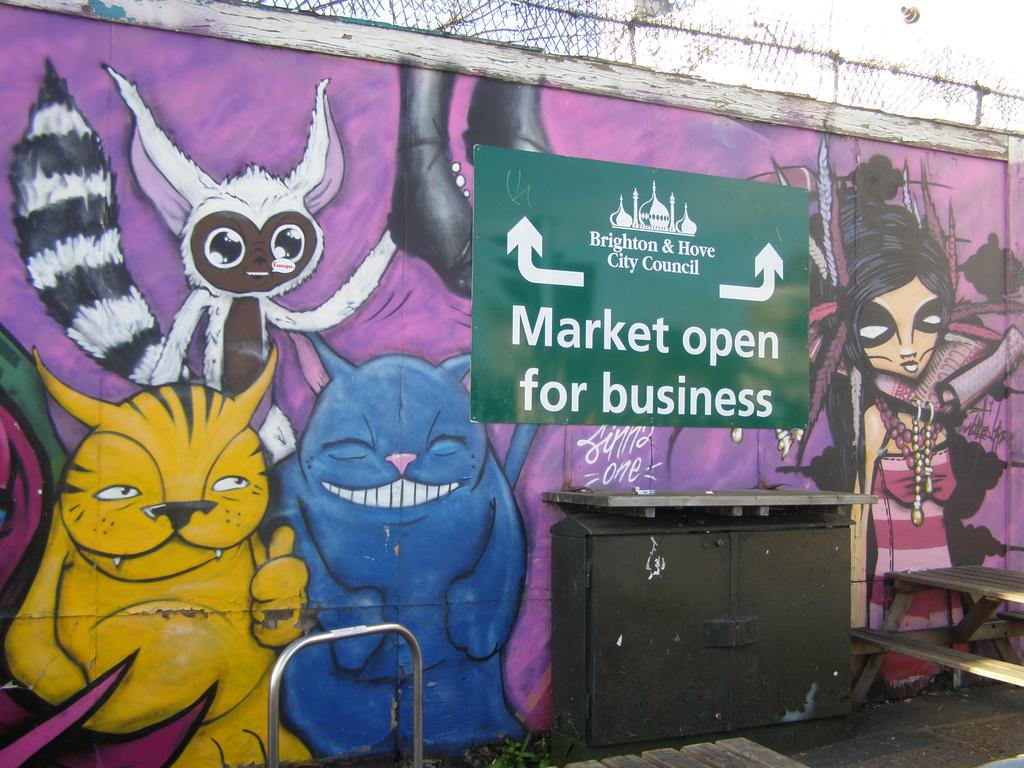What is depicted on the wall in the image? There is a wall with graffiti painting in the image. What else can be seen on the wall besides the graffiti? There is a poster with text in the image. What type of seating is present on the right side of the image? There is a wooden bench on the right side of the image. How does the graffiti painting on the wall affect the top of the poster? There is no interaction between the graffiti painting and the poster in the image, so it cannot be determined how one affects the other. 